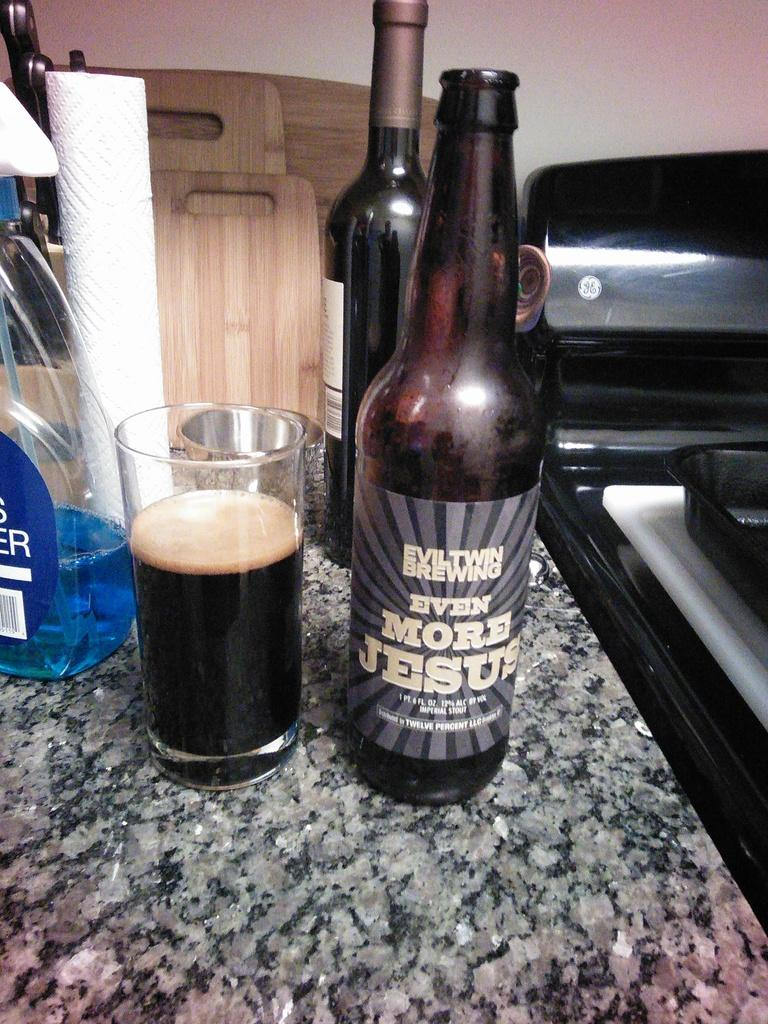<image>
Present a compact description of the photo's key features. A two thirds filled glass next to a bottle of Even More Jesus beer on a granite countertop. 